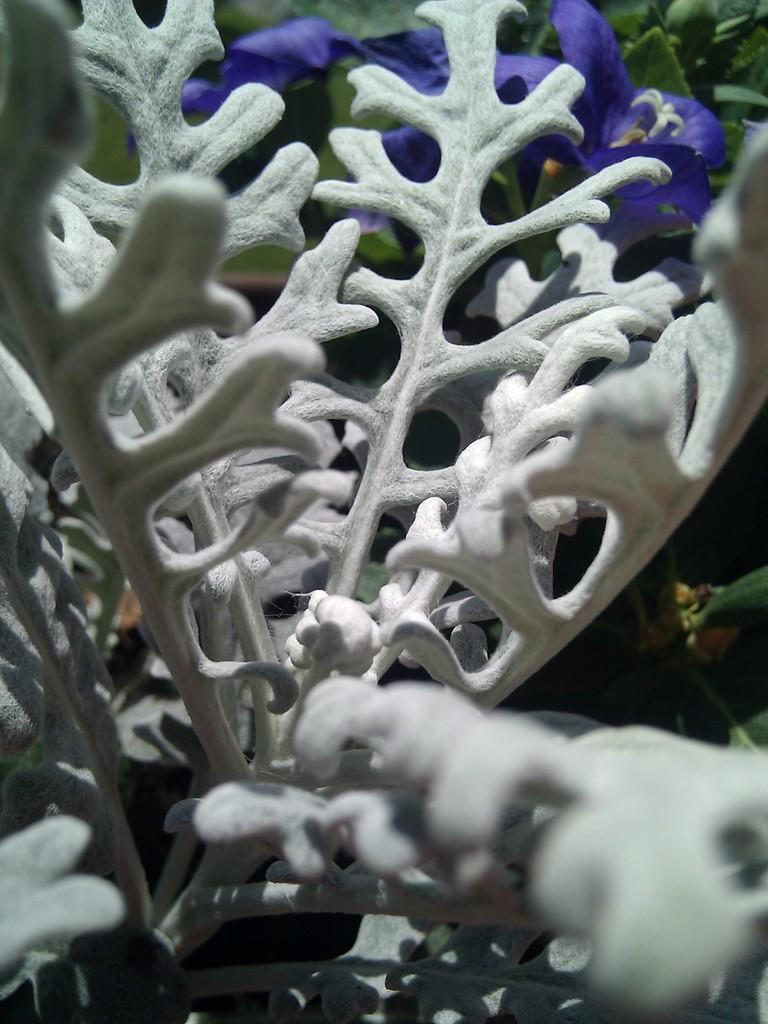How would you summarize this image in a sentence or two? In this image in the front there are flowers which are white in colour. In the background there are flowers and plants. 